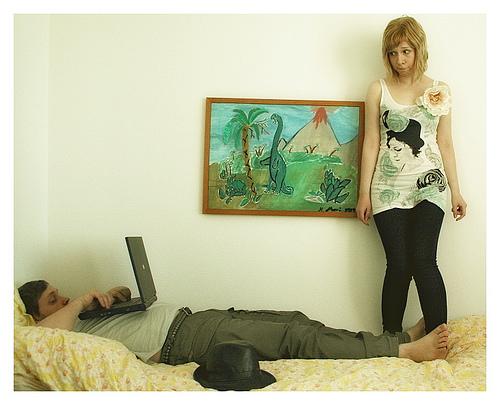Where is the painting?
Give a very brief answer. Wall. Is the picture crooked?
Short answer required. Yes. Does her shirt have sleeves?
Give a very brief answer. No. 